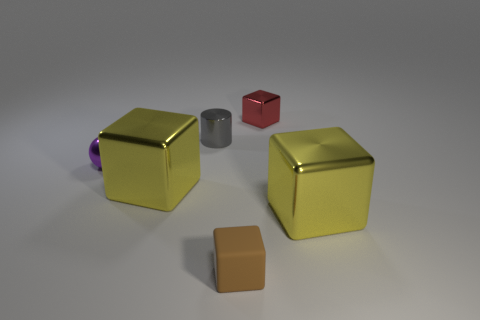How many other tiny metallic objects have the same shape as the small red metal object?
Provide a succinct answer. 0. There is a ball that is made of the same material as the red cube; what size is it?
Your answer should be compact. Small. Are there more purple matte cubes than small cylinders?
Your response must be concise. No. There is a small shiny object left of the gray cylinder; what color is it?
Provide a succinct answer. Purple. What is the size of the thing that is both in front of the small purple metal sphere and left of the brown cube?
Give a very brief answer. Large. How many gray metal cylinders have the same size as the brown object?
Provide a short and direct response. 1. There is a red thing that is the same shape as the small brown thing; what material is it?
Your response must be concise. Metal. Is the shape of the tiny matte object the same as the gray metallic thing?
Provide a short and direct response. No. There is a red cube; what number of small brown objects are in front of it?
Make the answer very short. 1. What is the shape of the large yellow thing that is on the right side of the small block that is behind the tiny matte thing?
Provide a succinct answer. Cube. 